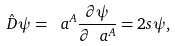Convert formula to latex. <formula><loc_0><loc_0><loc_500><loc_500>\hat { D } \psi = \ a ^ { A } \frac { \partial \psi } { \partial \ a ^ { A } } = 2 s \psi \/ ,</formula> 